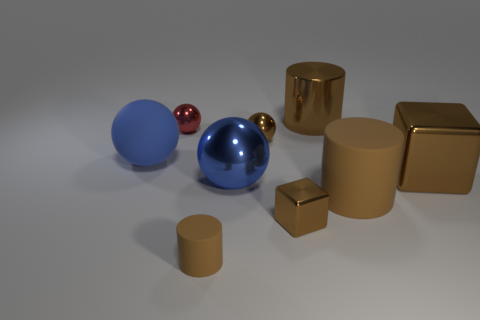What is the size of the object that is the same color as the matte ball?
Your answer should be compact. Large. Are there any other brown cubes made of the same material as the large brown block?
Provide a short and direct response. Yes. What color is the rubber sphere?
Offer a terse response. Blue. What is the size of the brown rubber cylinder that is behind the brown rubber thing in front of the brown matte thing to the right of the small rubber object?
Offer a very short reply. Large. How many other objects are the same shape as the tiny red thing?
Your response must be concise. 3. There is a cylinder that is both in front of the red ball and to the right of the small brown metallic sphere; what color is it?
Give a very brief answer. Brown. Is there anything else that is the same size as the brown shiny sphere?
Provide a succinct answer. Yes. Do the small ball that is on the left side of the small matte cylinder and the small rubber cylinder have the same color?
Give a very brief answer. No. How many cylinders are small rubber things or large blue rubber objects?
Provide a short and direct response. 1. What shape is the tiny brown shiny thing that is behind the blue metal sphere?
Provide a short and direct response. Sphere. 